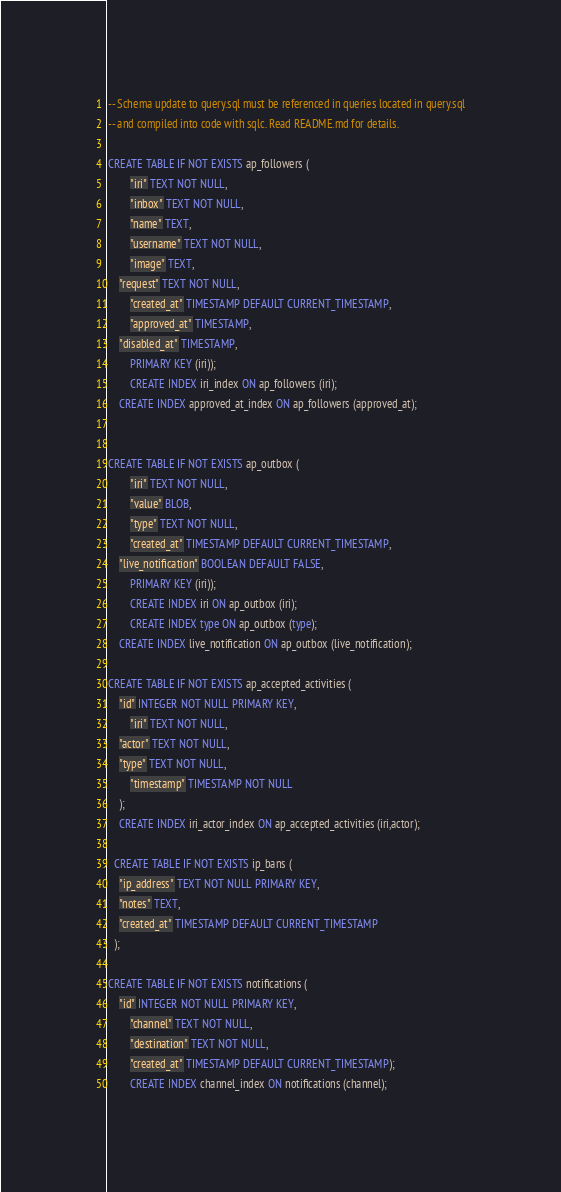<code> <loc_0><loc_0><loc_500><loc_500><_SQL_>-- Schema update to query.sql must be referenced in queries located in query.sql
-- and compiled into code with sqlc. Read README.md for details.

CREATE TABLE IF NOT EXISTS ap_followers (
		"iri" TEXT NOT NULL,
		"inbox" TEXT NOT NULL,
		"name" TEXT,
		"username" TEXT NOT NULL,
		"image" TEXT,
    "request" TEXT NOT NULL,
		"created_at" TIMESTAMP DEFAULT CURRENT_TIMESTAMP,
		"approved_at" TIMESTAMP,
    "disabled_at" TIMESTAMP,
		PRIMARY KEY (iri));
		CREATE INDEX iri_index ON ap_followers (iri);
    CREATE INDEX approved_at_index ON ap_followers (approved_at);


CREATE TABLE IF NOT EXISTS ap_outbox (
		"iri" TEXT NOT NULL,
		"value" BLOB,
		"type" TEXT NOT NULL,
		"created_at" TIMESTAMP DEFAULT CURRENT_TIMESTAMP,
    "live_notification" BOOLEAN DEFAULT FALSE,
		PRIMARY KEY (iri));
		CREATE INDEX iri ON ap_outbox (iri);
		CREATE INDEX type ON ap_outbox (type);
    CREATE INDEX live_notification ON ap_outbox (live_notification);

CREATE TABLE IF NOT EXISTS ap_accepted_activities (
    "id" INTEGER NOT NULL PRIMARY KEY,
		"iri" TEXT NOT NULL,
    "actor" TEXT NOT NULL,
    "type" TEXT NOT NULL,
		"timestamp" TIMESTAMP NOT NULL
	);
	CREATE INDEX iri_actor_index ON ap_accepted_activities (iri,actor);

  CREATE TABLE IF NOT EXISTS ip_bans (
    "ip_address" TEXT NOT NULL PRIMARY KEY,
    "notes" TEXT,
    "created_at" TIMESTAMP DEFAULT CURRENT_TIMESTAMP
  );

CREATE TABLE IF NOT EXISTS notifications (
    "id" INTEGER NOT NULL PRIMARY KEY,
		"channel" TEXT NOT NULL,
		"destination" TEXT NOT NULL,
		"created_at" TIMESTAMP DEFAULT CURRENT_TIMESTAMP);
		CREATE INDEX channel_index ON notifications (channel);
</code> 